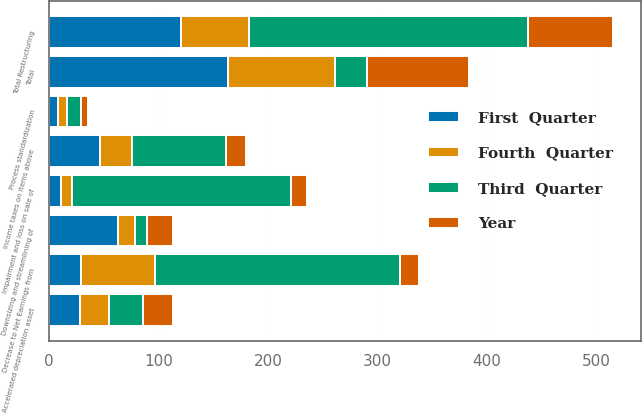<chart> <loc_0><loc_0><loc_500><loc_500><stacked_bar_chart><ecel><fcel>Downsizing and streamlining of<fcel>Impairment and loss on sale of<fcel>Accelerated depreciation asset<fcel>Process standardization<fcel>Total Restructuring<fcel>Total<fcel>Income taxes on items above<fcel>Decrease to Net Earnings from<nl><fcel>Third  Quarter<fcel>11<fcel>200<fcel>31<fcel>13<fcel>255<fcel>29<fcel>86<fcel>224<nl><fcel>Year<fcel>24<fcel>15<fcel>27<fcel>6<fcel>77<fcel>94<fcel>18<fcel>17<nl><fcel>Fourth  Quarter<fcel>15<fcel>10<fcel>27<fcel>8<fcel>63<fcel>98<fcel>30<fcel>68<nl><fcel>First  Quarter<fcel>63<fcel>11<fcel>28<fcel>8<fcel>120<fcel>163<fcel>46<fcel>29<nl></chart> 